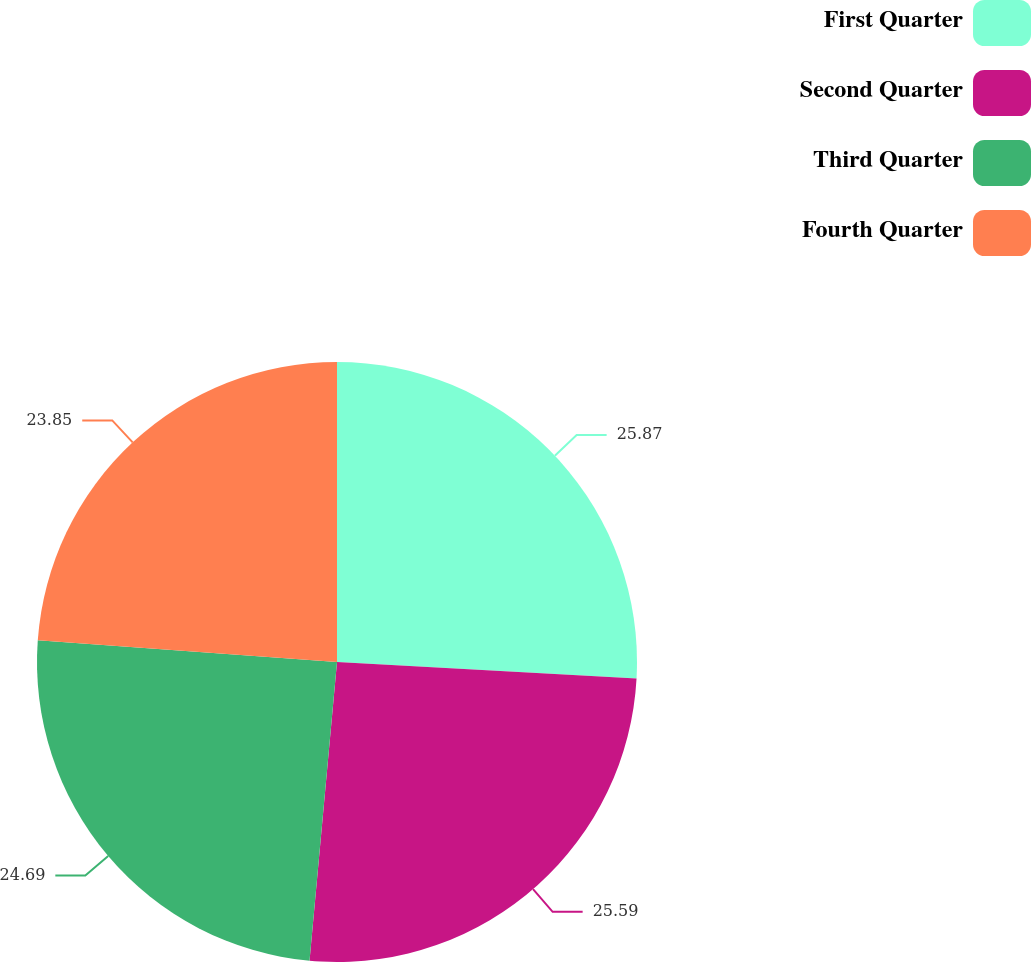<chart> <loc_0><loc_0><loc_500><loc_500><pie_chart><fcel>First Quarter<fcel>Second Quarter<fcel>Third Quarter<fcel>Fourth Quarter<nl><fcel>25.87%<fcel>25.59%<fcel>24.69%<fcel>23.85%<nl></chart> 